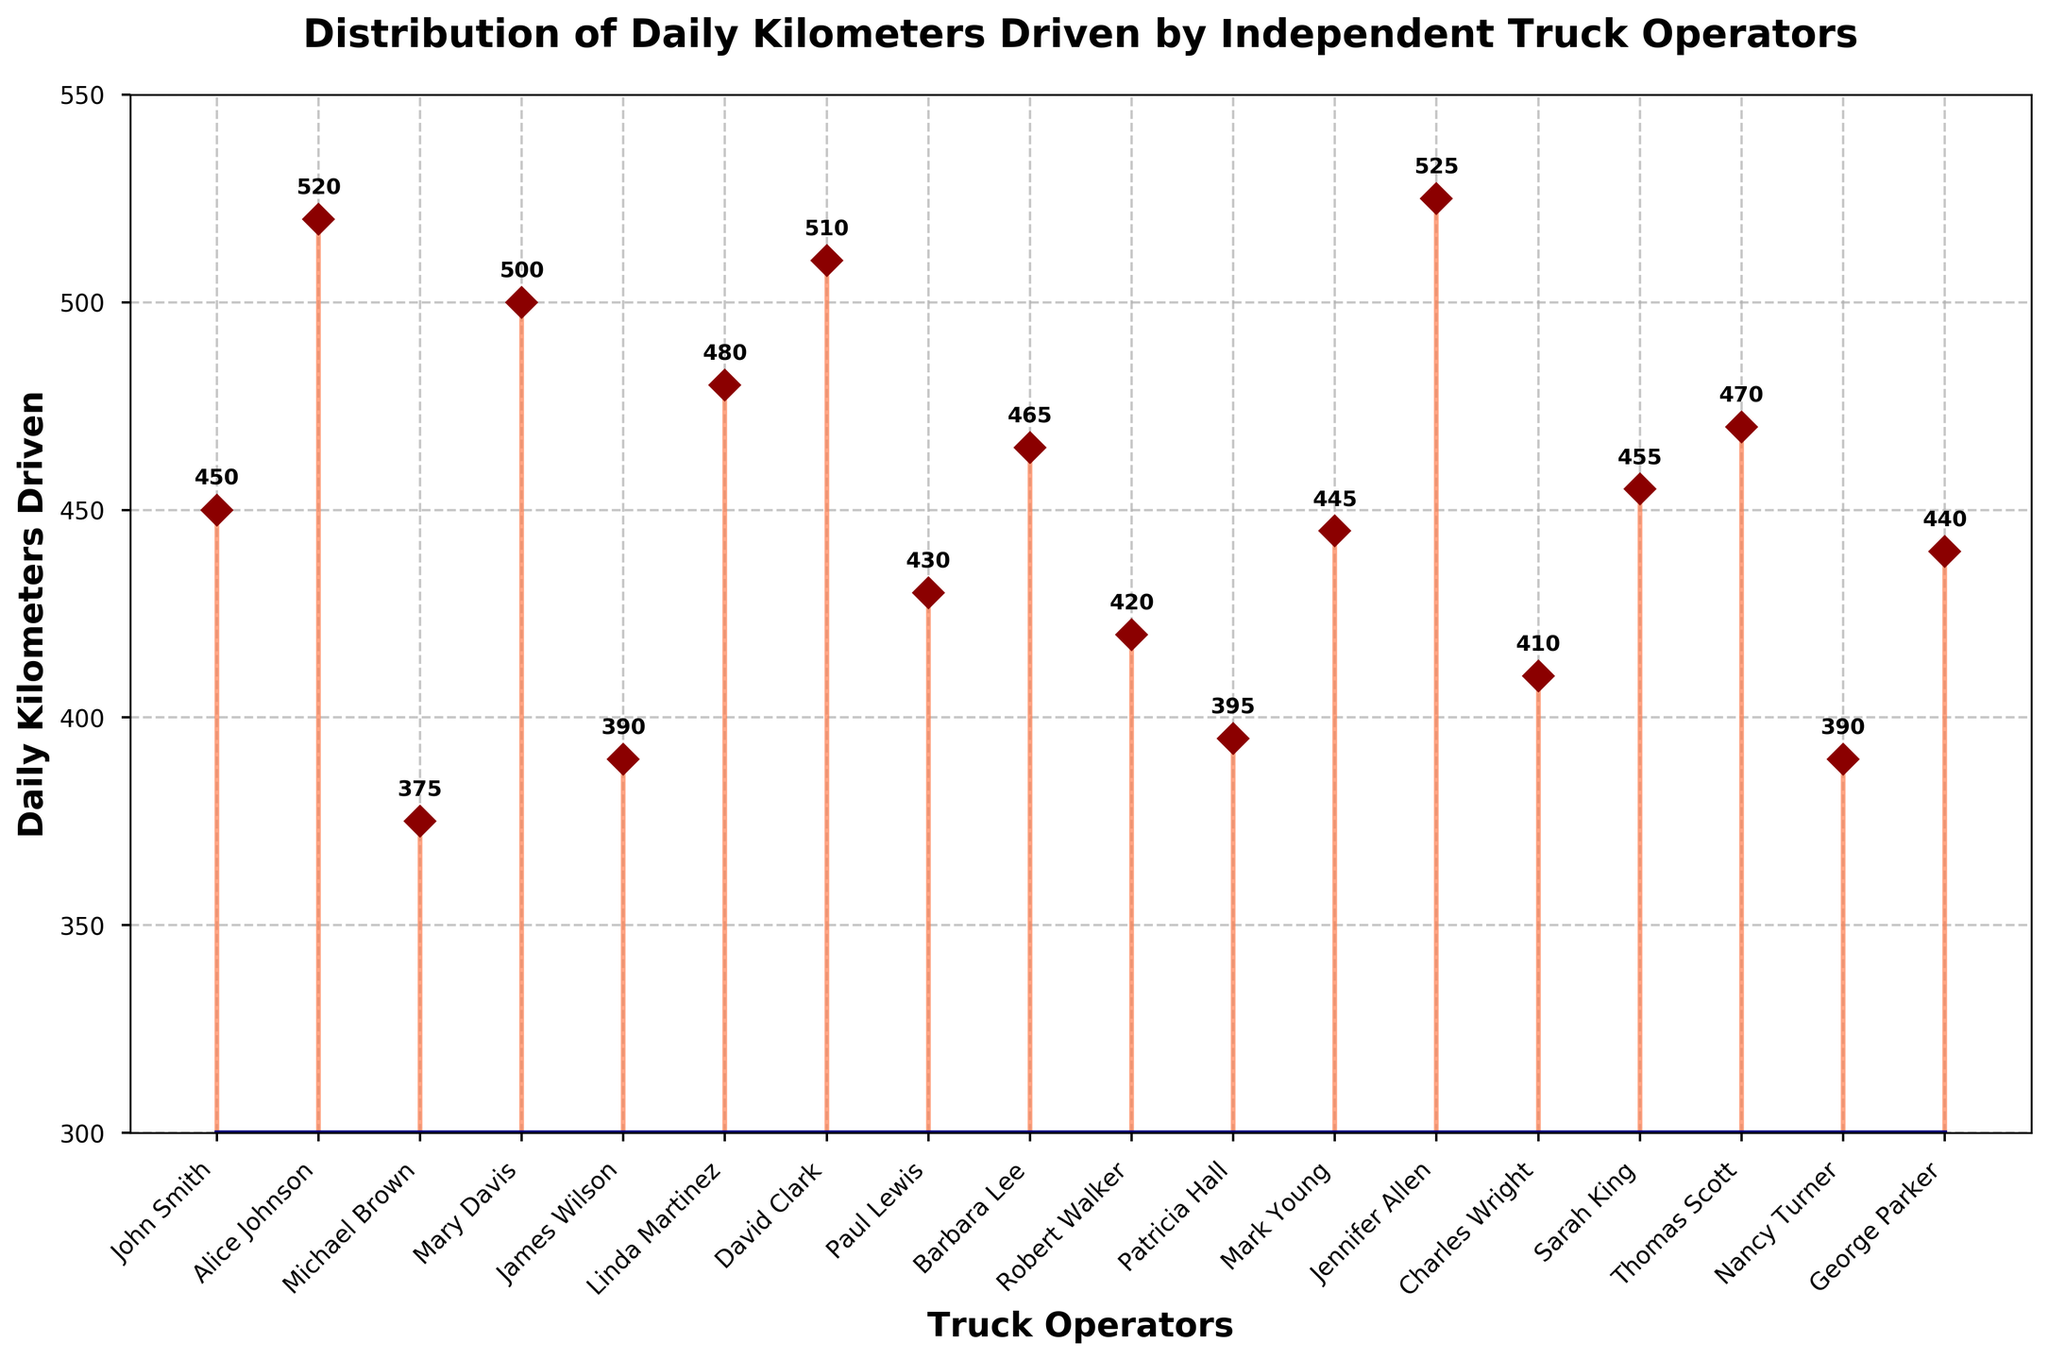What is the title of the chart? The title is located at the top of the chart in bold.
Answer: Distribution of Daily Kilometers Driven by Independent Truck Operators How many truck operators are displayed in the chart? The x-axis lists the names of each operator. Counting these names will give us the number of operators.
Answer: 17 What is the daily distance driven by the operator who drove the most kilometers? Look for the highest marker on the y-axis and check its corresponding label on the x-axis.
Answer: 525 kilometers by Jennifer Allen Which operator drove the least kilometers daily? Locate the lowest marker on the y-axis and find its associated name on the x-axis.
Answer: 375 kilometers by Michael Brown What is the average daily kilometers driven by Alice Johnson and Linda Martinez? Add Alice Johnson's 520 kilometers and Linda Martinez's 480 kilometers and then divide by two.
Answer: (520 + 480) / 2 = 500 kilometers How many operators drove more than 450 kilometers daily? Count the number of markers above the 450 kilometers line on the y-axis.
Answer: 8 Which operators drove exactly 390 kilometers daily? Find the markers on the y-axis at 390 kilometers and note their associated names on the x-axis.
Answer: James Wilson and Nancy Turner Between John Smith and George Parker, who drove a longer distance daily? Compare the markers for John Smith (450 kilometers) and George Parker (440 kilometers) on the y-axis.
Answer: John Smith What is the range of daily kilometers driven among all operators? Subtract the smallest value (375 kilometers by Michael Brown) from the largest value (525 kilometers by Jennifer Allen).
Answer: 525 - 375 = 150 kilometers Is the majority of the operators' daily kilometers driven closer to the higher or lower end of the y-axis? Observe the distribution of the markers along the y-axis to determine if they cluster more towards the higher or lower end.
Answer: Closer to the higher end, as many markers are near and above 450 kilometers 